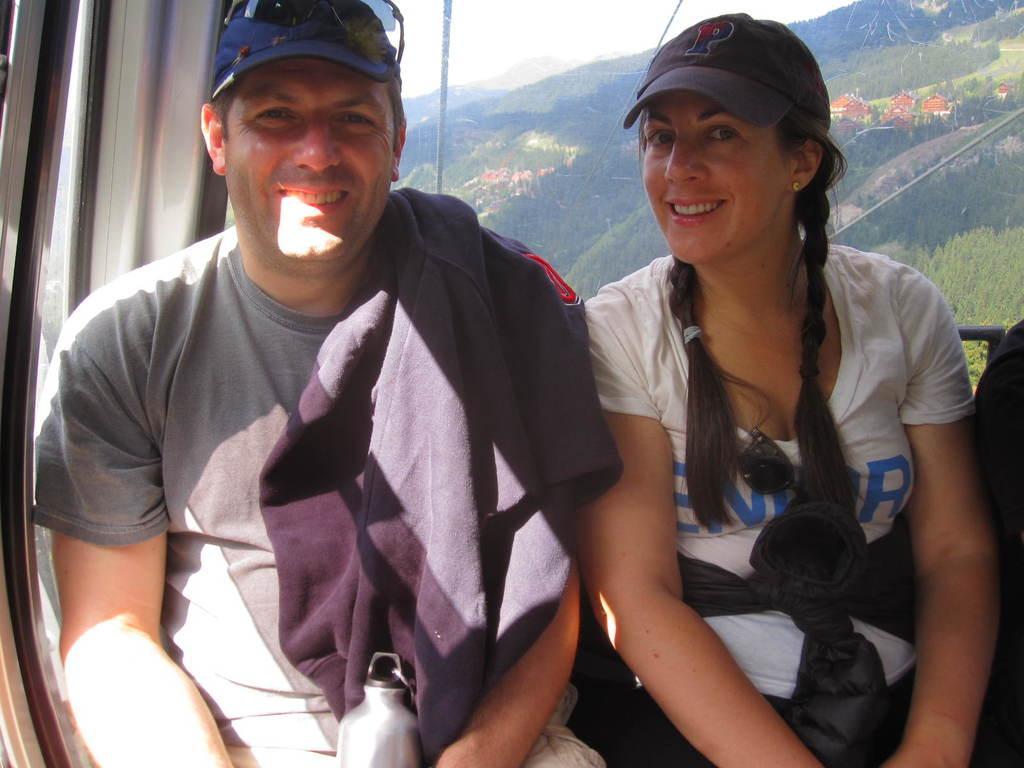Could you give a brief overview of what you see in this image? In the picture we can see a man and a woman sitting together in the cable cart, they are wearing a T-shirts and caps and smiling and behind them, we can see a glass from it we can see hills with trees, houses and behind it we can see a sky. 